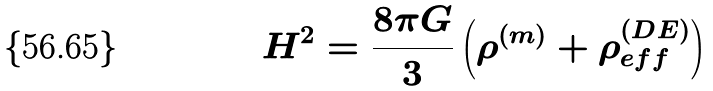Convert formula to latex. <formula><loc_0><loc_0><loc_500><loc_500>H ^ { 2 } = \frac { 8 \pi G } { 3 } \left ( \rho ^ { ( m ) } + \rho ^ { ( D E ) } _ { e f f } \right )</formula> 